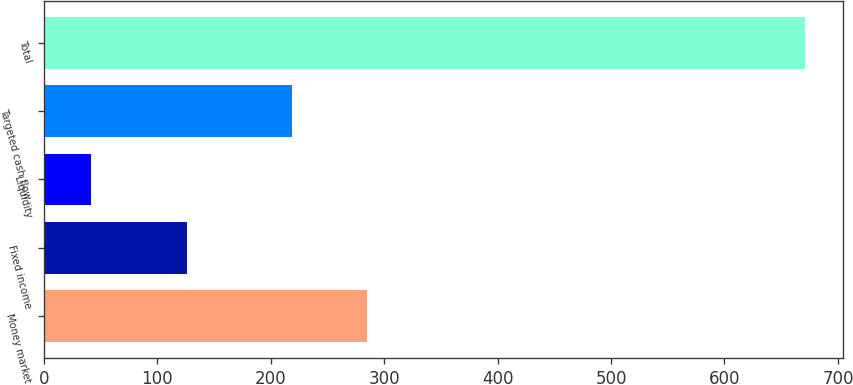<chart> <loc_0><loc_0><loc_500><loc_500><bar_chart><fcel>Money market<fcel>Fixed income<fcel>Liquidity<fcel>Targeted cash flow<fcel>Total<nl><fcel>285<fcel>126<fcel>41<fcel>219<fcel>671<nl></chart> 